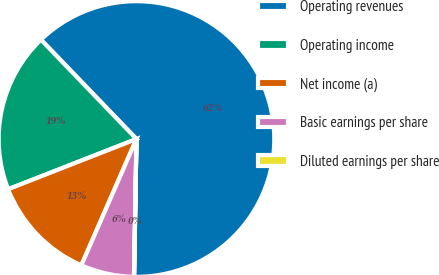Convert chart to OTSL. <chart><loc_0><loc_0><loc_500><loc_500><pie_chart><fcel>Operating revenues<fcel>Operating income<fcel>Net income (a)<fcel>Basic earnings per share<fcel>Diluted earnings per share<nl><fcel>62.47%<fcel>18.75%<fcel>12.51%<fcel>6.26%<fcel>0.02%<nl></chart> 